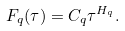<formula> <loc_0><loc_0><loc_500><loc_500>F _ { q } ( \tau ) = C _ { q } \tau ^ { H _ { q } } .</formula> 